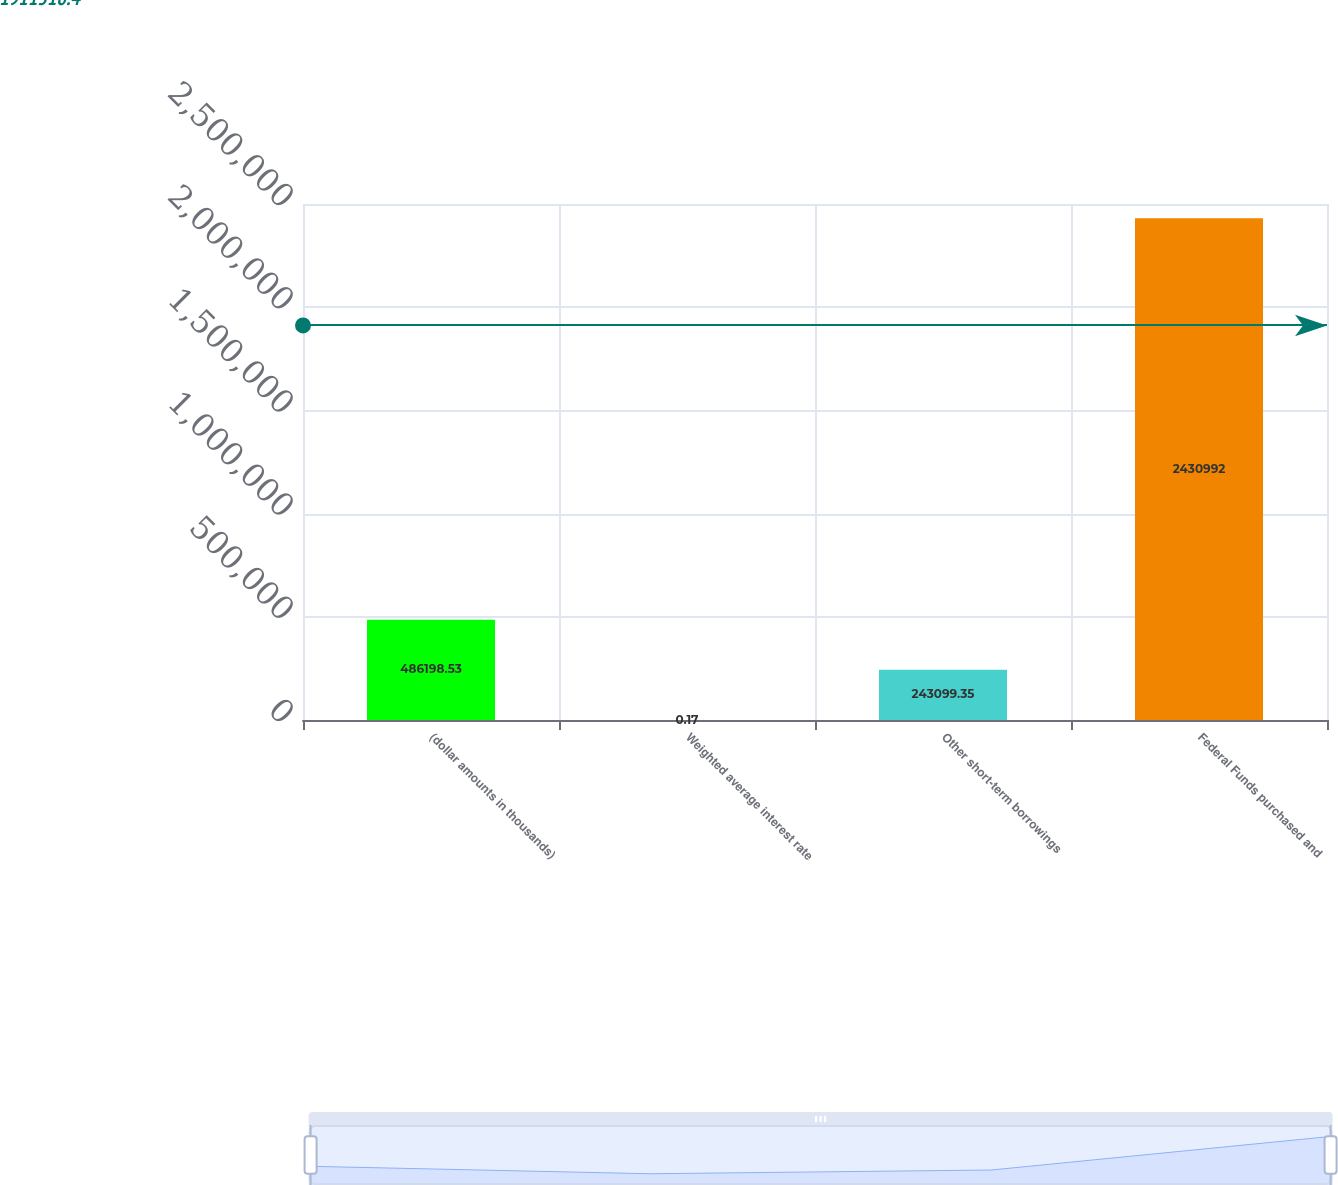Convert chart to OTSL. <chart><loc_0><loc_0><loc_500><loc_500><bar_chart><fcel>(dollar amounts in thousands)<fcel>Weighted average interest rate<fcel>Other short-term borrowings<fcel>Federal Funds purchased and<nl><fcel>486199<fcel>0.17<fcel>243099<fcel>2.43099e+06<nl></chart> 